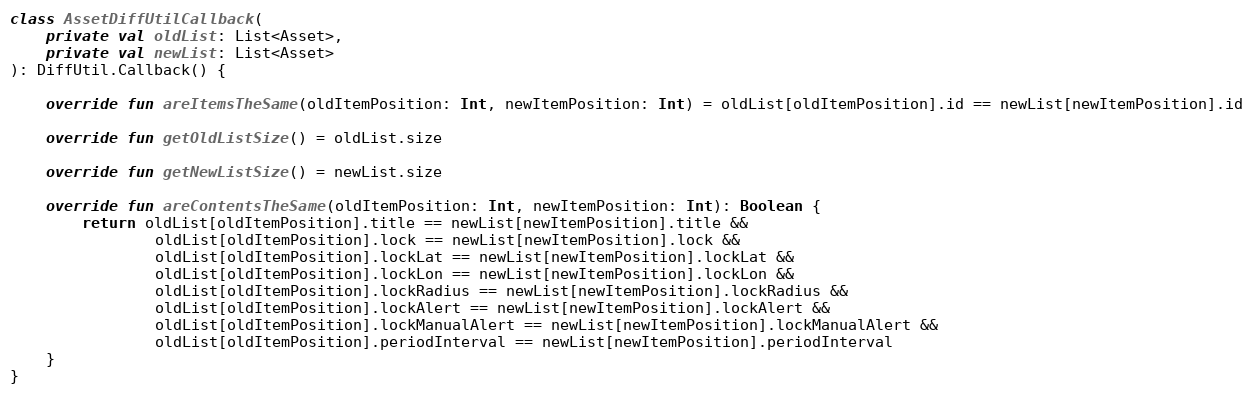Convert code to text. <code><loc_0><loc_0><loc_500><loc_500><_Kotlin_>

class AssetDiffUtilCallback(
    private val oldList: List<Asset>,
    private val newList: List<Asset>
): DiffUtil.Callback() {

    override fun areItemsTheSame(oldItemPosition: Int, newItemPosition: Int) = oldList[oldItemPosition].id == newList[newItemPosition].id

    override fun getOldListSize() = oldList.size

    override fun getNewListSize() = newList.size

    override fun areContentsTheSame(oldItemPosition: Int, newItemPosition: Int): Boolean {
        return oldList[oldItemPosition].title == newList[newItemPosition].title &&
                oldList[oldItemPosition].lock == newList[newItemPosition].lock &&
                oldList[oldItemPosition].lockLat == newList[newItemPosition].lockLat &&
                oldList[oldItemPosition].lockLon == newList[newItemPosition].lockLon &&
                oldList[oldItemPosition].lockRadius == newList[newItemPosition].lockRadius &&
                oldList[oldItemPosition].lockAlert == newList[newItemPosition].lockAlert &&
                oldList[oldItemPosition].lockManualAlert == newList[newItemPosition].lockManualAlert &&
                oldList[oldItemPosition].periodInterval == newList[newItemPosition].periodInterval
    }
}
</code> 